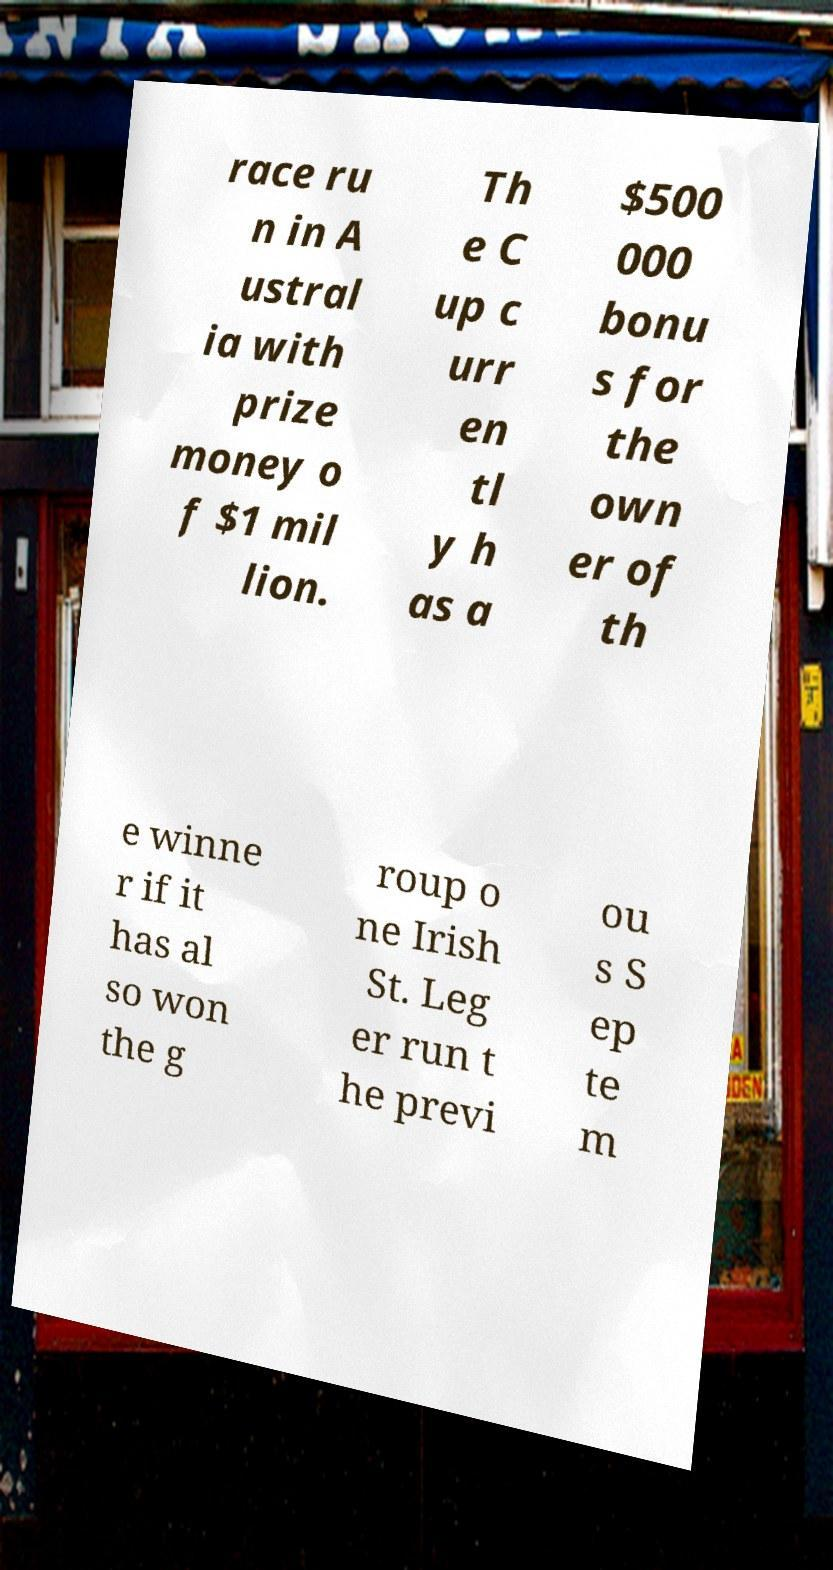Can you accurately transcribe the text from the provided image for me? race ru n in A ustral ia with prize money o f $1 mil lion. Th e C up c urr en tl y h as a $500 000 bonu s for the own er of th e winne r if it has al so won the g roup o ne Irish St. Leg er run t he previ ou s S ep te m 